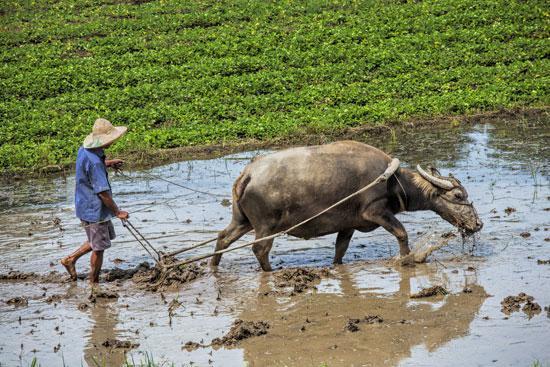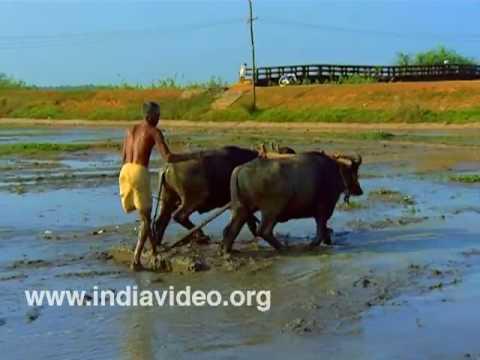The first image is the image on the left, the second image is the image on the right. Given the left and right images, does the statement "At least one image shows a team of two oxen pulling a plow with a man behind it." hold true? Answer yes or no. Yes. 